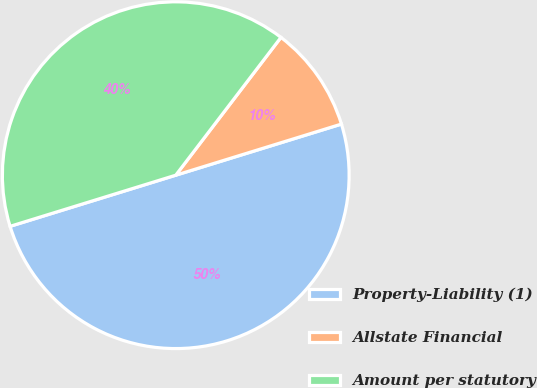<chart> <loc_0><loc_0><loc_500><loc_500><pie_chart><fcel>Property-Liability (1)<fcel>Allstate Financial<fcel>Amount per statutory<nl><fcel>50.0%<fcel>9.86%<fcel>40.14%<nl></chart> 